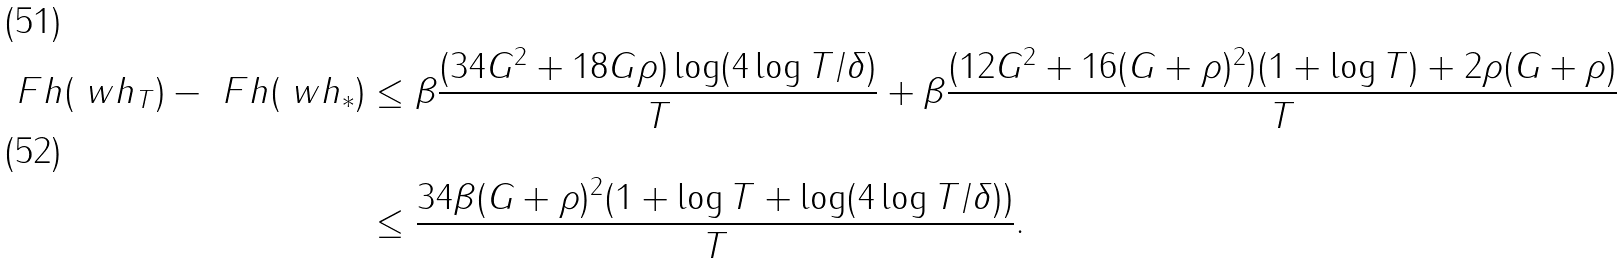<formula> <loc_0><loc_0><loc_500><loc_500>\ F h ( \ w h _ { T } ) - \ F h ( \ w h _ { * } ) & \leq \beta \frac { ( 3 4 G ^ { 2 } + 1 8 G \rho ) \log ( 4 \log T / \delta ) } { T } + \beta \frac { ( 1 2 G ^ { 2 } + 1 6 ( G + \rho ) ^ { 2 } ) ( 1 + \log T ) + 2 \rho ( G + \rho ) } { T } \\ & \leq \frac { 3 4 \beta ( G + \rho ) ^ { 2 } ( 1 + \log T + \log ( 4 \log T / \delta ) ) } { T } .</formula> 